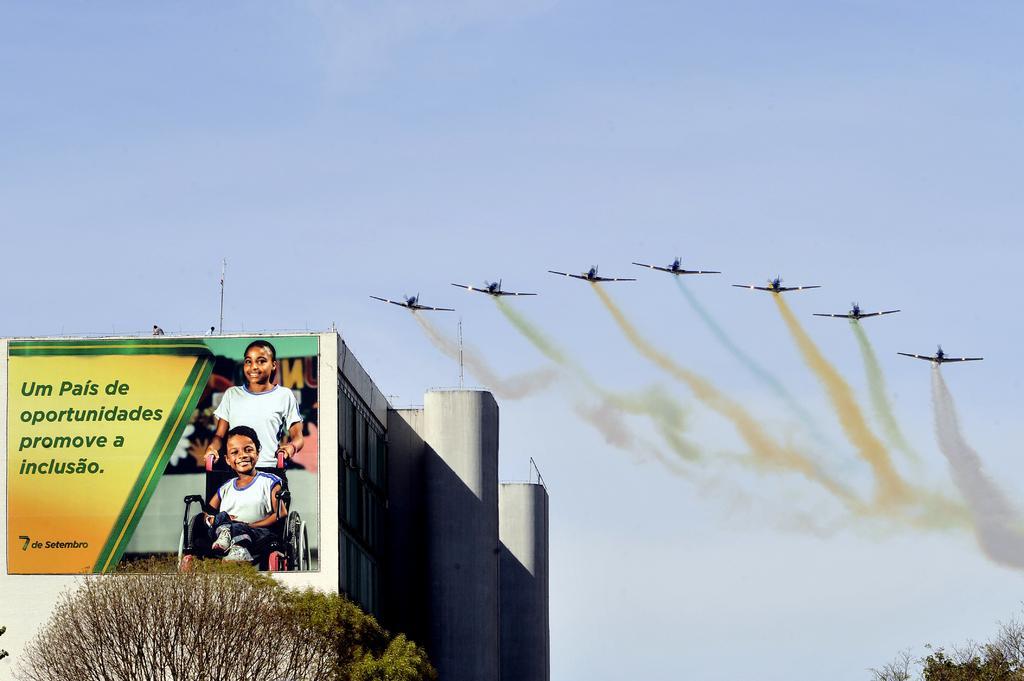Describe this image in one or two sentences. On the left side of the picture, we see a building in white color. We see a hoarding board in green and yellow color is placed on the building. We see two men are standing on the terrace of the building. In the left bottom of the picture, we see a tree. In the right bottom of the picture, we see a tree. At the top of the picture, we see the sky and jet planes flying in the sky. 